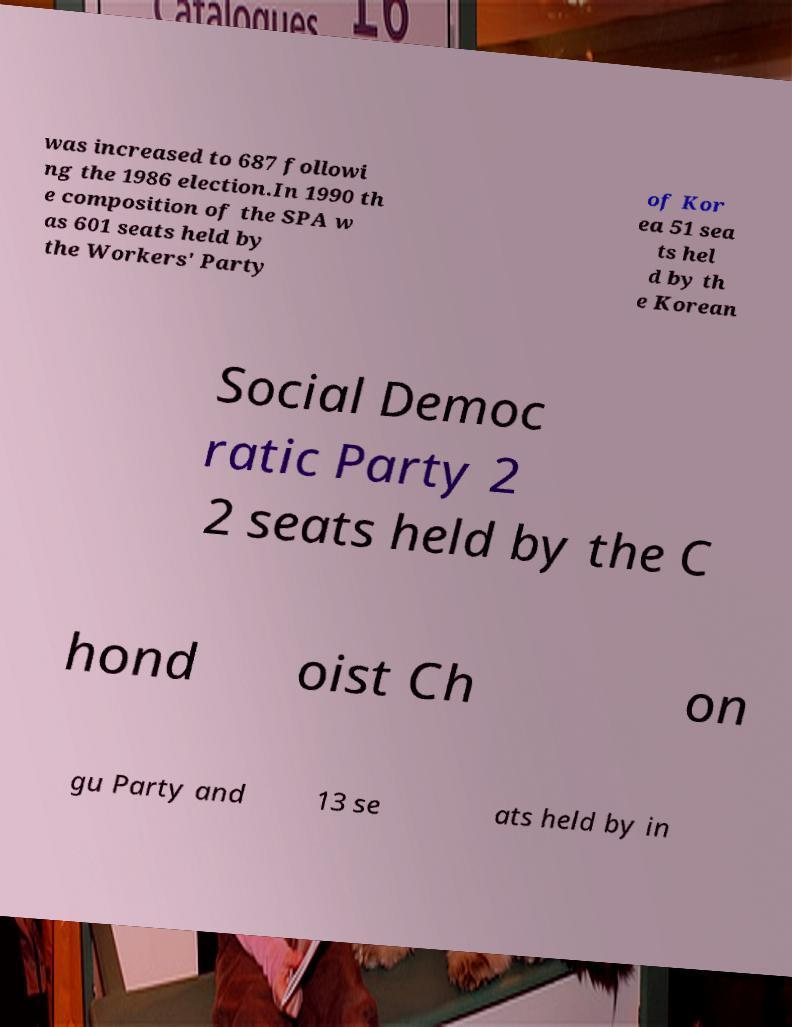What messages or text are displayed in this image? I need them in a readable, typed format. was increased to 687 followi ng the 1986 election.In 1990 th e composition of the SPA w as 601 seats held by the Workers' Party of Kor ea 51 sea ts hel d by th e Korean Social Democ ratic Party 2 2 seats held by the C hond oist Ch on gu Party and 13 se ats held by in 